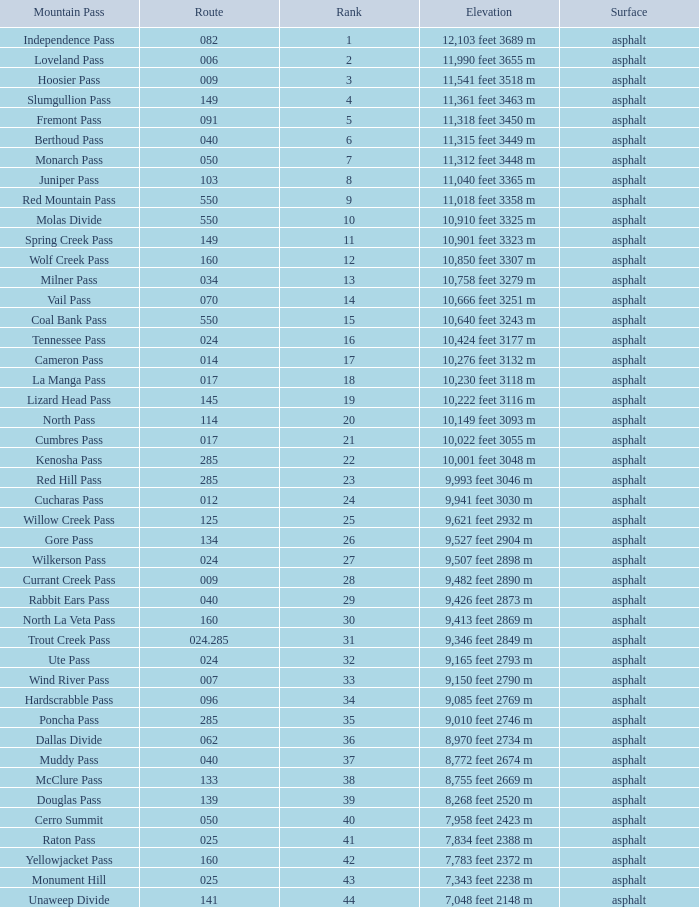What Mountain Pass has an Elevation of 10,001 feet 3048 m? Kenosha Pass. 